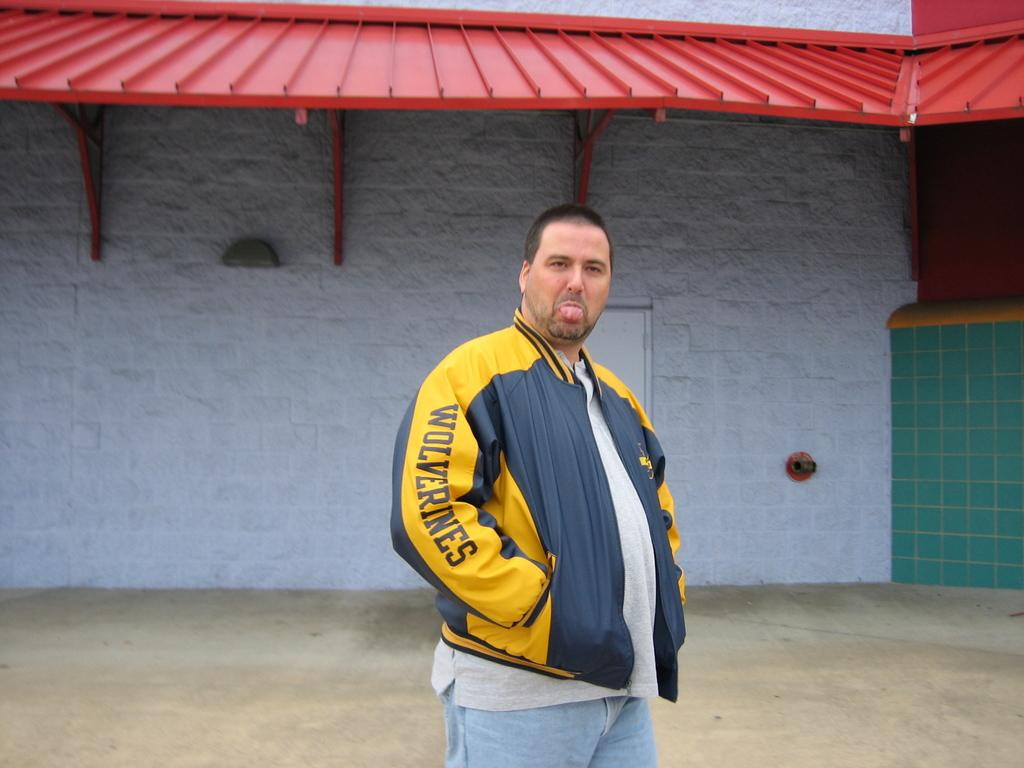<image>
Create a compact narrative representing the image presented. a man wearing a wolverines coat is in front of a building 